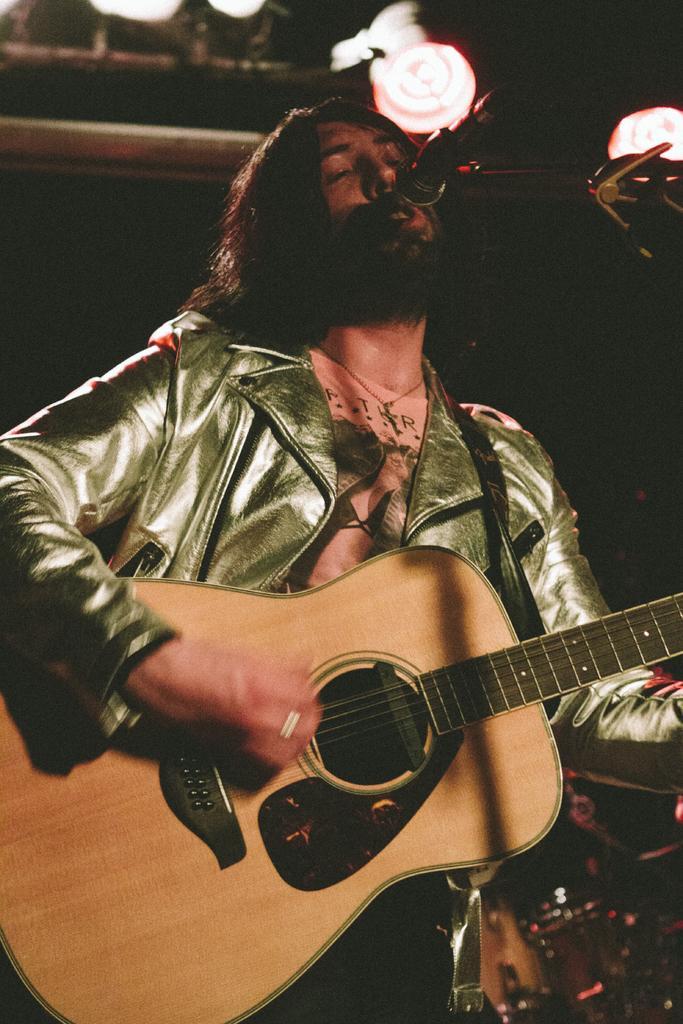Could you give a brief overview of what you see in this image? In this image i can see a person holding a guitar and a microphone in front of him. 